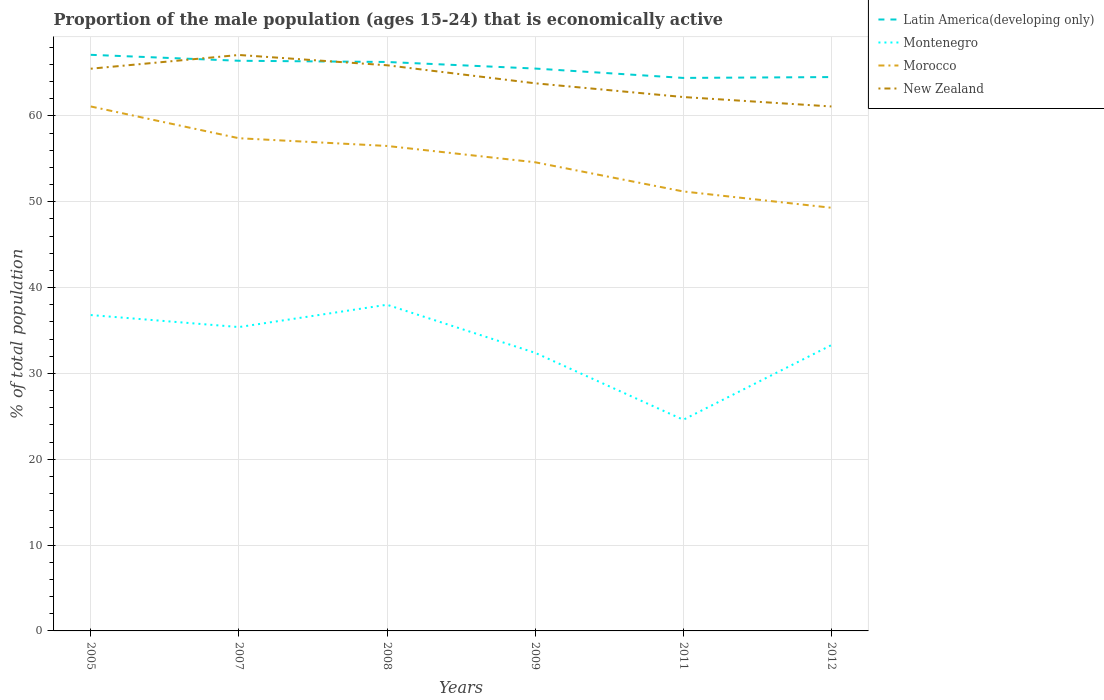Is the number of lines equal to the number of legend labels?
Provide a short and direct response. Yes. Across all years, what is the maximum proportion of the male population that is economically active in Montenegro?
Keep it short and to the point. 24.6. What is the total proportion of the male population that is economically active in New Zealand in the graph?
Offer a terse response. 1.7. What is the difference between the highest and the second highest proportion of the male population that is economically active in Latin America(developing only)?
Offer a very short reply. 2.69. What is the difference between the highest and the lowest proportion of the male population that is economically active in Morocco?
Ensure brevity in your answer.  3. How many lines are there?
Your answer should be very brief. 4. What is the difference between two consecutive major ticks on the Y-axis?
Your answer should be very brief. 10. Does the graph contain any zero values?
Ensure brevity in your answer.  No. Does the graph contain grids?
Your response must be concise. Yes. How are the legend labels stacked?
Offer a very short reply. Vertical. What is the title of the graph?
Provide a short and direct response. Proportion of the male population (ages 15-24) that is economically active. What is the label or title of the X-axis?
Your answer should be very brief. Years. What is the label or title of the Y-axis?
Offer a terse response. % of total population. What is the % of total population in Latin America(developing only) in 2005?
Your response must be concise. 67.12. What is the % of total population in Montenegro in 2005?
Your response must be concise. 36.8. What is the % of total population in Morocco in 2005?
Ensure brevity in your answer.  61.1. What is the % of total population in New Zealand in 2005?
Make the answer very short. 65.5. What is the % of total population of Latin America(developing only) in 2007?
Your answer should be compact. 66.43. What is the % of total population in Montenegro in 2007?
Ensure brevity in your answer.  35.4. What is the % of total population in Morocco in 2007?
Provide a succinct answer. 57.4. What is the % of total population of New Zealand in 2007?
Provide a succinct answer. 67.1. What is the % of total population of Latin America(developing only) in 2008?
Keep it short and to the point. 66.28. What is the % of total population in Morocco in 2008?
Offer a terse response. 56.5. What is the % of total population in New Zealand in 2008?
Offer a terse response. 65.9. What is the % of total population of Latin America(developing only) in 2009?
Offer a very short reply. 65.52. What is the % of total population in Montenegro in 2009?
Keep it short and to the point. 32.4. What is the % of total population in Morocco in 2009?
Offer a very short reply. 54.6. What is the % of total population in New Zealand in 2009?
Your response must be concise. 63.8. What is the % of total population of Latin America(developing only) in 2011?
Provide a succinct answer. 64.43. What is the % of total population of Montenegro in 2011?
Ensure brevity in your answer.  24.6. What is the % of total population in Morocco in 2011?
Your response must be concise. 51.2. What is the % of total population of New Zealand in 2011?
Provide a succinct answer. 62.2. What is the % of total population of Latin America(developing only) in 2012?
Make the answer very short. 64.52. What is the % of total population of Montenegro in 2012?
Your answer should be very brief. 33.3. What is the % of total population of Morocco in 2012?
Your response must be concise. 49.3. What is the % of total population in New Zealand in 2012?
Provide a short and direct response. 61.1. Across all years, what is the maximum % of total population in Latin America(developing only)?
Offer a terse response. 67.12. Across all years, what is the maximum % of total population in Montenegro?
Give a very brief answer. 38. Across all years, what is the maximum % of total population in Morocco?
Keep it short and to the point. 61.1. Across all years, what is the maximum % of total population in New Zealand?
Give a very brief answer. 67.1. Across all years, what is the minimum % of total population of Latin America(developing only)?
Offer a terse response. 64.43. Across all years, what is the minimum % of total population of Montenegro?
Keep it short and to the point. 24.6. Across all years, what is the minimum % of total population in Morocco?
Ensure brevity in your answer.  49.3. Across all years, what is the minimum % of total population in New Zealand?
Make the answer very short. 61.1. What is the total % of total population in Latin America(developing only) in the graph?
Give a very brief answer. 394.29. What is the total % of total population of Montenegro in the graph?
Offer a terse response. 200.5. What is the total % of total population of Morocco in the graph?
Your answer should be compact. 330.1. What is the total % of total population of New Zealand in the graph?
Your answer should be compact. 385.6. What is the difference between the % of total population in Latin America(developing only) in 2005 and that in 2007?
Your answer should be compact. 0.69. What is the difference between the % of total population in Morocco in 2005 and that in 2007?
Offer a terse response. 3.7. What is the difference between the % of total population of Latin America(developing only) in 2005 and that in 2008?
Give a very brief answer. 0.83. What is the difference between the % of total population in Montenegro in 2005 and that in 2008?
Provide a short and direct response. -1.2. What is the difference between the % of total population of New Zealand in 2005 and that in 2008?
Your answer should be very brief. -0.4. What is the difference between the % of total population in Latin America(developing only) in 2005 and that in 2009?
Offer a very short reply. 1.6. What is the difference between the % of total population in Montenegro in 2005 and that in 2009?
Your response must be concise. 4.4. What is the difference between the % of total population of New Zealand in 2005 and that in 2009?
Keep it short and to the point. 1.7. What is the difference between the % of total population of Latin America(developing only) in 2005 and that in 2011?
Offer a terse response. 2.69. What is the difference between the % of total population of New Zealand in 2005 and that in 2011?
Provide a short and direct response. 3.3. What is the difference between the % of total population in Latin America(developing only) in 2005 and that in 2012?
Provide a succinct answer. 2.59. What is the difference between the % of total population in Montenegro in 2005 and that in 2012?
Your answer should be compact. 3.5. What is the difference between the % of total population of Latin America(developing only) in 2007 and that in 2008?
Your response must be concise. 0.14. What is the difference between the % of total population in Montenegro in 2007 and that in 2008?
Offer a very short reply. -2.6. What is the difference between the % of total population of New Zealand in 2007 and that in 2008?
Give a very brief answer. 1.2. What is the difference between the % of total population of Latin America(developing only) in 2007 and that in 2009?
Your answer should be very brief. 0.91. What is the difference between the % of total population of Montenegro in 2007 and that in 2009?
Ensure brevity in your answer.  3. What is the difference between the % of total population of Morocco in 2007 and that in 2009?
Your answer should be very brief. 2.8. What is the difference between the % of total population in Latin America(developing only) in 2007 and that in 2011?
Your response must be concise. 2. What is the difference between the % of total population of Morocco in 2007 and that in 2011?
Your response must be concise. 6.2. What is the difference between the % of total population of Latin America(developing only) in 2007 and that in 2012?
Your answer should be very brief. 1.9. What is the difference between the % of total population of Montenegro in 2007 and that in 2012?
Provide a short and direct response. 2.1. What is the difference between the % of total population in Latin America(developing only) in 2008 and that in 2009?
Give a very brief answer. 0.77. What is the difference between the % of total population of New Zealand in 2008 and that in 2009?
Provide a short and direct response. 2.1. What is the difference between the % of total population in Latin America(developing only) in 2008 and that in 2011?
Offer a terse response. 1.86. What is the difference between the % of total population of Montenegro in 2008 and that in 2011?
Make the answer very short. 13.4. What is the difference between the % of total population of New Zealand in 2008 and that in 2011?
Provide a short and direct response. 3.7. What is the difference between the % of total population in Latin America(developing only) in 2008 and that in 2012?
Your response must be concise. 1.76. What is the difference between the % of total population of Montenegro in 2008 and that in 2012?
Provide a short and direct response. 4.7. What is the difference between the % of total population of Morocco in 2008 and that in 2012?
Your answer should be very brief. 7.2. What is the difference between the % of total population of New Zealand in 2008 and that in 2012?
Your response must be concise. 4.8. What is the difference between the % of total population of Latin America(developing only) in 2009 and that in 2011?
Ensure brevity in your answer.  1.09. What is the difference between the % of total population in Latin America(developing only) in 2009 and that in 2012?
Provide a short and direct response. 0.99. What is the difference between the % of total population in Morocco in 2009 and that in 2012?
Give a very brief answer. 5.3. What is the difference between the % of total population in New Zealand in 2009 and that in 2012?
Offer a very short reply. 2.7. What is the difference between the % of total population in Latin America(developing only) in 2011 and that in 2012?
Your answer should be very brief. -0.1. What is the difference between the % of total population of Montenegro in 2011 and that in 2012?
Ensure brevity in your answer.  -8.7. What is the difference between the % of total population of New Zealand in 2011 and that in 2012?
Offer a very short reply. 1.1. What is the difference between the % of total population in Latin America(developing only) in 2005 and the % of total population in Montenegro in 2007?
Make the answer very short. 31.72. What is the difference between the % of total population of Latin America(developing only) in 2005 and the % of total population of Morocco in 2007?
Your answer should be compact. 9.72. What is the difference between the % of total population in Latin America(developing only) in 2005 and the % of total population in New Zealand in 2007?
Ensure brevity in your answer.  0.02. What is the difference between the % of total population in Montenegro in 2005 and the % of total population in Morocco in 2007?
Keep it short and to the point. -20.6. What is the difference between the % of total population of Montenegro in 2005 and the % of total population of New Zealand in 2007?
Give a very brief answer. -30.3. What is the difference between the % of total population of Latin America(developing only) in 2005 and the % of total population of Montenegro in 2008?
Ensure brevity in your answer.  29.12. What is the difference between the % of total population of Latin America(developing only) in 2005 and the % of total population of Morocco in 2008?
Your response must be concise. 10.62. What is the difference between the % of total population in Latin America(developing only) in 2005 and the % of total population in New Zealand in 2008?
Make the answer very short. 1.22. What is the difference between the % of total population in Montenegro in 2005 and the % of total population in Morocco in 2008?
Offer a very short reply. -19.7. What is the difference between the % of total population of Montenegro in 2005 and the % of total population of New Zealand in 2008?
Ensure brevity in your answer.  -29.1. What is the difference between the % of total population in Latin America(developing only) in 2005 and the % of total population in Montenegro in 2009?
Provide a short and direct response. 34.72. What is the difference between the % of total population in Latin America(developing only) in 2005 and the % of total population in Morocco in 2009?
Keep it short and to the point. 12.52. What is the difference between the % of total population of Latin America(developing only) in 2005 and the % of total population of New Zealand in 2009?
Give a very brief answer. 3.32. What is the difference between the % of total population of Montenegro in 2005 and the % of total population of Morocco in 2009?
Provide a short and direct response. -17.8. What is the difference between the % of total population of Latin America(developing only) in 2005 and the % of total population of Montenegro in 2011?
Keep it short and to the point. 42.52. What is the difference between the % of total population of Latin America(developing only) in 2005 and the % of total population of Morocco in 2011?
Provide a short and direct response. 15.92. What is the difference between the % of total population in Latin America(developing only) in 2005 and the % of total population in New Zealand in 2011?
Your answer should be very brief. 4.92. What is the difference between the % of total population of Montenegro in 2005 and the % of total population of Morocco in 2011?
Your answer should be compact. -14.4. What is the difference between the % of total population in Montenegro in 2005 and the % of total population in New Zealand in 2011?
Keep it short and to the point. -25.4. What is the difference between the % of total population in Morocco in 2005 and the % of total population in New Zealand in 2011?
Offer a terse response. -1.1. What is the difference between the % of total population in Latin America(developing only) in 2005 and the % of total population in Montenegro in 2012?
Offer a terse response. 33.82. What is the difference between the % of total population in Latin America(developing only) in 2005 and the % of total population in Morocco in 2012?
Ensure brevity in your answer.  17.82. What is the difference between the % of total population in Latin America(developing only) in 2005 and the % of total population in New Zealand in 2012?
Offer a very short reply. 6.02. What is the difference between the % of total population in Montenegro in 2005 and the % of total population in Morocco in 2012?
Offer a very short reply. -12.5. What is the difference between the % of total population in Montenegro in 2005 and the % of total population in New Zealand in 2012?
Provide a succinct answer. -24.3. What is the difference between the % of total population of Latin America(developing only) in 2007 and the % of total population of Montenegro in 2008?
Your response must be concise. 28.43. What is the difference between the % of total population in Latin America(developing only) in 2007 and the % of total population in Morocco in 2008?
Keep it short and to the point. 9.93. What is the difference between the % of total population of Latin America(developing only) in 2007 and the % of total population of New Zealand in 2008?
Your response must be concise. 0.53. What is the difference between the % of total population in Montenegro in 2007 and the % of total population in Morocco in 2008?
Give a very brief answer. -21.1. What is the difference between the % of total population of Montenegro in 2007 and the % of total population of New Zealand in 2008?
Keep it short and to the point. -30.5. What is the difference between the % of total population of Latin America(developing only) in 2007 and the % of total population of Montenegro in 2009?
Provide a succinct answer. 34.03. What is the difference between the % of total population of Latin America(developing only) in 2007 and the % of total population of Morocco in 2009?
Keep it short and to the point. 11.83. What is the difference between the % of total population in Latin America(developing only) in 2007 and the % of total population in New Zealand in 2009?
Make the answer very short. 2.63. What is the difference between the % of total population in Montenegro in 2007 and the % of total population in Morocco in 2009?
Provide a short and direct response. -19.2. What is the difference between the % of total population in Montenegro in 2007 and the % of total population in New Zealand in 2009?
Your response must be concise. -28.4. What is the difference between the % of total population in Morocco in 2007 and the % of total population in New Zealand in 2009?
Keep it short and to the point. -6.4. What is the difference between the % of total population of Latin America(developing only) in 2007 and the % of total population of Montenegro in 2011?
Your answer should be compact. 41.83. What is the difference between the % of total population in Latin America(developing only) in 2007 and the % of total population in Morocco in 2011?
Keep it short and to the point. 15.23. What is the difference between the % of total population of Latin America(developing only) in 2007 and the % of total population of New Zealand in 2011?
Your answer should be very brief. 4.23. What is the difference between the % of total population of Montenegro in 2007 and the % of total population of Morocco in 2011?
Offer a very short reply. -15.8. What is the difference between the % of total population in Montenegro in 2007 and the % of total population in New Zealand in 2011?
Make the answer very short. -26.8. What is the difference between the % of total population in Morocco in 2007 and the % of total population in New Zealand in 2011?
Provide a short and direct response. -4.8. What is the difference between the % of total population in Latin America(developing only) in 2007 and the % of total population in Montenegro in 2012?
Provide a succinct answer. 33.13. What is the difference between the % of total population in Latin America(developing only) in 2007 and the % of total population in Morocco in 2012?
Your answer should be very brief. 17.13. What is the difference between the % of total population of Latin America(developing only) in 2007 and the % of total population of New Zealand in 2012?
Ensure brevity in your answer.  5.33. What is the difference between the % of total population of Montenegro in 2007 and the % of total population of Morocco in 2012?
Provide a short and direct response. -13.9. What is the difference between the % of total population in Montenegro in 2007 and the % of total population in New Zealand in 2012?
Give a very brief answer. -25.7. What is the difference between the % of total population in Latin America(developing only) in 2008 and the % of total population in Montenegro in 2009?
Your response must be concise. 33.88. What is the difference between the % of total population of Latin America(developing only) in 2008 and the % of total population of Morocco in 2009?
Make the answer very short. 11.68. What is the difference between the % of total population of Latin America(developing only) in 2008 and the % of total population of New Zealand in 2009?
Your answer should be very brief. 2.48. What is the difference between the % of total population of Montenegro in 2008 and the % of total population of Morocco in 2009?
Provide a succinct answer. -16.6. What is the difference between the % of total population in Montenegro in 2008 and the % of total population in New Zealand in 2009?
Provide a succinct answer. -25.8. What is the difference between the % of total population in Latin America(developing only) in 2008 and the % of total population in Montenegro in 2011?
Make the answer very short. 41.68. What is the difference between the % of total population of Latin America(developing only) in 2008 and the % of total population of Morocco in 2011?
Offer a very short reply. 15.08. What is the difference between the % of total population in Latin America(developing only) in 2008 and the % of total population in New Zealand in 2011?
Offer a terse response. 4.08. What is the difference between the % of total population of Montenegro in 2008 and the % of total population of Morocco in 2011?
Provide a short and direct response. -13.2. What is the difference between the % of total population in Montenegro in 2008 and the % of total population in New Zealand in 2011?
Make the answer very short. -24.2. What is the difference between the % of total population of Morocco in 2008 and the % of total population of New Zealand in 2011?
Give a very brief answer. -5.7. What is the difference between the % of total population of Latin America(developing only) in 2008 and the % of total population of Montenegro in 2012?
Offer a terse response. 32.98. What is the difference between the % of total population in Latin America(developing only) in 2008 and the % of total population in Morocco in 2012?
Provide a succinct answer. 16.98. What is the difference between the % of total population in Latin America(developing only) in 2008 and the % of total population in New Zealand in 2012?
Provide a short and direct response. 5.18. What is the difference between the % of total population of Montenegro in 2008 and the % of total population of Morocco in 2012?
Your answer should be compact. -11.3. What is the difference between the % of total population of Montenegro in 2008 and the % of total population of New Zealand in 2012?
Keep it short and to the point. -23.1. What is the difference between the % of total population of Latin America(developing only) in 2009 and the % of total population of Montenegro in 2011?
Ensure brevity in your answer.  40.92. What is the difference between the % of total population of Latin America(developing only) in 2009 and the % of total population of Morocco in 2011?
Offer a terse response. 14.32. What is the difference between the % of total population in Latin America(developing only) in 2009 and the % of total population in New Zealand in 2011?
Provide a succinct answer. 3.32. What is the difference between the % of total population in Montenegro in 2009 and the % of total population in Morocco in 2011?
Offer a terse response. -18.8. What is the difference between the % of total population in Montenegro in 2009 and the % of total population in New Zealand in 2011?
Provide a succinct answer. -29.8. What is the difference between the % of total population in Morocco in 2009 and the % of total population in New Zealand in 2011?
Offer a very short reply. -7.6. What is the difference between the % of total population in Latin America(developing only) in 2009 and the % of total population in Montenegro in 2012?
Ensure brevity in your answer.  32.22. What is the difference between the % of total population in Latin America(developing only) in 2009 and the % of total population in Morocco in 2012?
Give a very brief answer. 16.22. What is the difference between the % of total population in Latin America(developing only) in 2009 and the % of total population in New Zealand in 2012?
Provide a short and direct response. 4.42. What is the difference between the % of total population of Montenegro in 2009 and the % of total population of Morocco in 2012?
Make the answer very short. -16.9. What is the difference between the % of total population of Montenegro in 2009 and the % of total population of New Zealand in 2012?
Your answer should be compact. -28.7. What is the difference between the % of total population in Morocco in 2009 and the % of total population in New Zealand in 2012?
Your response must be concise. -6.5. What is the difference between the % of total population in Latin America(developing only) in 2011 and the % of total population in Montenegro in 2012?
Offer a terse response. 31.13. What is the difference between the % of total population of Latin America(developing only) in 2011 and the % of total population of Morocco in 2012?
Your response must be concise. 15.13. What is the difference between the % of total population of Latin America(developing only) in 2011 and the % of total population of New Zealand in 2012?
Provide a short and direct response. 3.33. What is the difference between the % of total population of Montenegro in 2011 and the % of total population of Morocco in 2012?
Your response must be concise. -24.7. What is the difference between the % of total population of Montenegro in 2011 and the % of total population of New Zealand in 2012?
Provide a short and direct response. -36.5. What is the average % of total population in Latin America(developing only) per year?
Your response must be concise. 65.72. What is the average % of total population in Montenegro per year?
Your answer should be compact. 33.42. What is the average % of total population of Morocco per year?
Ensure brevity in your answer.  55.02. What is the average % of total population in New Zealand per year?
Make the answer very short. 64.27. In the year 2005, what is the difference between the % of total population of Latin America(developing only) and % of total population of Montenegro?
Your answer should be compact. 30.32. In the year 2005, what is the difference between the % of total population of Latin America(developing only) and % of total population of Morocco?
Give a very brief answer. 6.02. In the year 2005, what is the difference between the % of total population in Latin America(developing only) and % of total population in New Zealand?
Make the answer very short. 1.62. In the year 2005, what is the difference between the % of total population in Montenegro and % of total population in Morocco?
Offer a very short reply. -24.3. In the year 2005, what is the difference between the % of total population in Montenegro and % of total population in New Zealand?
Give a very brief answer. -28.7. In the year 2007, what is the difference between the % of total population in Latin America(developing only) and % of total population in Montenegro?
Your answer should be compact. 31.03. In the year 2007, what is the difference between the % of total population in Latin America(developing only) and % of total population in Morocco?
Ensure brevity in your answer.  9.03. In the year 2007, what is the difference between the % of total population in Latin America(developing only) and % of total population in New Zealand?
Your answer should be compact. -0.67. In the year 2007, what is the difference between the % of total population in Montenegro and % of total population in Morocco?
Offer a very short reply. -22. In the year 2007, what is the difference between the % of total population of Montenegro and % of total population of New Zealand?
Ensure brevity in your answer.  -31.7. In the year 2008, what is the difference between the % of total population of Latin America(developing only) and % of total population of Montenegro?
Provide a short and direct response. 28.28. In the year 2008, what is the difference between the % of total population of Latin America(developing only) and % of total population of Morocco?
Ensure brevity in your answer.  9.78. In the year 2008, what is the difference between the % of total population of Latin America(developing only) and % of total population of New Zealand?
Keep it short and to the point. 0.38. In the year 2008, what is the difference between the % of total population of Montenegro and % of total population of Morocco?
Provide a short and direct response. -18.5. In the year 2008, what is the difference between the % of total population in Montenegro and % of total population in New Zealand?
Your answer should be very brief. -27.9. In the year 2008, what is the difference between the % of total population of Morocco and % of total population of New Zealand?
Your answer should be very brief. -9.4. In the year 2009, what is the difference between the % of total population in Latin America(developing only) and % of total population in Montenegro?
Your answer should be compact. 33.12. In the year 2009, what is the difference between the % of total population of Latin America(developing only) and % of total population of Morocco?
Make the answer very short. 10.92. In the year 2009, what is the difference between the % of total population in Latin America(developing only) and % of total population in New Zealand?
Provide a short and direct response. 1.72. In the year 2009, what is the difference between the % of total population in Montenegro and % of total population in Morocco?
Provide a succinct answer. -22.2. In the year 2009, what is the difference between the % of total population of Montenegro and % of total population of New Zealand?
Your response must be concise. -31.4. In the year 2011, what is the difference between the % of total population in Latin America(developing only) and % of total population in Montenegro?
Offer a very short reply. 39.83. In the year 2011, what is the difference between the % of total population of Latin America(developing only) and % of total population of Morocco?
Make the answer very short. 13.23. In the year 2011, what is the difference between the % of total population of Latin America(developing only) and % of total population of New Zealand?
Give a very brief answer. 2.23. In the year 2011, what is the difference between the % of total population in Montenegro and % of total population in Morocco?
Provide a succinct answer. -26.6. In the year 2011, what is the difference between the % of total population in Montenegro and % of total population in New Zealand?
Give a very brief answer. -37.6. In the year 2012, what is the difference between the % of total population of Latin America(developing only) and % of total population of Montenegro?
Make the answer very short. 31.22. In the year 2012, what is the difference between the % of total population in Latin America(developing only) and % of total population in Morocco?
Offer a very short reply. 15.22. In the year 2012, what is the difference between the % of total population in Latin America(developing only) and % of total population in New Zealand?
Your answer should be compact. 3.42. In the year 2012, what is the difference between the % of total population of Montenegro and % of total population of New Zealand?
Ensure brevity in your answer.  -27.8. In the year 2012, what is the difference between the % of total population of Morocco and % of total population of New Zealand?
Offer a terse response. -11.8. What is the ratio of the % of total population in Latin America(developing only) in 2005 to that in 2007?
Ensure brevity in your answer.  1.01. What is the ratio of the % of total population of Montenegro in 2005 to that in 2007?
Ensure brevity in your answer.  1.04. What is the ratio of the % of total population of Morocco in 2005 to that in 2007?
Give a very brief answer. 1.06. What is the ratio of the % of total population in New Zealand in 2005 to that in 2007?
Your response must be concise. 0.98. What is the ratio of the % of total population of Latin America(developing only) in 2005 to that in 2008?
Offer a very short reply. 1.01. What is the ratio of the % of total population in Montenegro in 2005 to that in 2008?
Offer a terse response. 0.97. What is the ratio of the % of total population of Morocco in 2005 to that in 2008?
Your response must be concise. 1.08. What is the ratio of the % of total population of New Zealand in 2005 to that in 2008?
Offer a very short reply. 0.99. What is the ratio of the % of total population of Latin America(developing only) in 2005 to that in 2009?
Give a very brief answer. 1.02. What is the ratio of the % of total population of Montenegro in 2005 to that in 2009?
Offer a terse response. 1.14. What is the ratio of the % of total population of Morocco in 2005 to that in 2009?
Your response must be concise. 1.12. What is the ratio of the % of total population in New Zealand in 2005 to that in 2009?
Make the answer very short. 1.03. What is the ratio of the % of total population of Latin America(developing only) in 2005 to that in 2011?
Your answer should be very brief. 1.04. What is the ratio of the % of total population in Montenegro in 2005 to that in 2011?
Keep it short and to the point. 1.5. What is the ratio of the % of total population in Morocco in 2005 to that in 2011?
Offer a very short reply. 1.19. What is the ratio of the % of total population of New Zealand in 2005 to that in 2011?
Make the answer very short. 1.05. What is the ratio of the % of total population of Latin America(developing only) in 2005 to that in 2012?
Provide a short and direct response. 1.04. What is the ratio of the % of total population of Montenegro in 2005 to that in 2012?
Your answer should be very brief. 1.11. What is the ratio of the % of total population of Morocco in 2005 to that in 2012?
Offer a very short reply. 1.24. What is the ratio of the % of total population in New Zealand in 2005 to that in 2012?
Offer a very short reply. 1.07. What is the ratio of the % of total population in Montenegro in 2007 to that in 2008?
Give a very brief answer. 0.93. What is the ratio of the % of total population in Morocco in 2007 to that in 2008?
Your answer should be compact. 1.02. What is the ratio of the % of total population of New Zealand in 2007 to that in 2008?
Make the answer very short. 1.02. What is the ratio of the % of total population in Latin America(developing only) in 2007 to that in 2009?
Provide a short and direct response. 1.01. What is the ratio of the % of total population in Montenegro in 2007 to that in 2009?
Give a very brief answer. 1.09. What is the ratio of the % of total population in Morocco in 2007 to that in 2009?
Offer a very short reply. 1.05. What is the ratio of the % of total population in New Zealand in 2007 to that in 2009?
Ensure brevity in your answer.  1.05. What is the ratio of the % of total population of Latin America(developing only) in 2007 to that in 2011?
Your answer should be very brief. 1.03. What is the ratio of the % of total population in Montenegro in 2007 to that in 2011?
Your response must be concise. 1.44. What is the ratio of the % of total population in Morocco in 2007 to that in 2011?
Keep it short and to the point. 1.12. What is the ratio of the % of total population of New Zealand in 2007 to that in 2011?
Provide a short and direct response. 1.08. What is the ratio of the % of total population in Latin America(developing only) in 2007 to that in 2012?
Provide a succinct answer. 1.03. What is the ratio of the % of total population of Montenegro in 2007 to that in 2012?
Keep it short and to the point. 1.06. What is the ratio of the % of total population of Morocco in 2007 to that in 2012?
Keep it short and to the point. 1.16. What is the ratio of the % of total population in New Zealand in 2007 to that in 2012?
Provide a succinct answer. 1.1. What is the ratio of the % of total population of Latin America(developing only) in 2008 to that in 2009?
Ensure brevity in your answer.  1.01. What is the ratio of the % of total population of Montenegro in 2008 to that in 2009?
Give a very brief answer. 1.17. What is the ratio of the % of total population of Morocco in 2008 to that in 2009?
Provide a succinct answer. 1.03. What is the ratio of the % of total population in New Zealand in 2008 to that in 2009?
Give a very brief answer. 1.03. What is the ratio of the % of total population of Latin America(developing only) in 2008 to that in 2011?
Offer a very short reply. 1.03. What is the ratio of the % of total population in Montenegro in 2008 to that in 2011?
Make the answer very short. 1.54. What is the ratio of the % of total population in Morocco in 2008 to that in 2011?
Offer a very short reply. 1.1. What is the ratio of the % of total population in New Zealand in 2008 to that in 2011?
Give a very brief answer. 1.06. What is the ratio of the % of total population in Latin America(developing only) in 2008 to that in 2012?
Provide a short and direct response. 1.03. What is the ratio of the % of total population of Montenegro in 2008 to that in 2012?
Provide a short and direct response. 1.14. What is the ratio of the % of total population of Morocco in 2008 to that in 2012?
Provide a short and direct response. 1.15. What is the ratio of the % of total population in New Zealand in 2008 to that in 2012?
Your answer should be compact. 1.08. What is the ratio of the % of total population in Latin America(developing only) in 2009 to that in 2011?
Provide a short and direct response. 1.02. What is the ratio of the % of total population of Montenegro in 2009 to that in 2011?
Your response must be concise. 1.32. What is the ratio of the % of total population of Morocco in 2009 to that in 2011?
Provide a succinct answer. 1.07. What is the ratio of the % of total population in New Zealand in 2009 to that in 2011?
Make the answer very short. 1.03. What is the ratio of the % of total population in Latin America(developing only) in 2009 to that in 2012?
Ensure brevity in your answer.  1.02. What is the ratio of the % of total population of Montenegro in 2009 to that in 2012?
Ensure brevity in your answer.  0.97. What is the ratio of the % of total population of Morocco in 2009 to that in 2012?
Provide a succinct answer. 1.11. What is the ratio of the % of total population in New Zealand in 2009 to that in 2012?
Your answer should be very brief. 1.04. What is the ratio of the % of total population of Latin America(developing only) in 2011 to that in 2012?
Make the answer very short. 1. What is the ratio of the % of total population of Montenegro in 2011 to that in 2012?
Your answer should be very brief. 0.74. What is the difference between the highest and the second highest % of total population of Latin America(developing only)?
Offer a terse response. 0.69. What is the difference between the highest and the second highest % of total population in Montenegro?
Your answer should be compact. 1.2. What is the difference between the highest and the second highest % of total population of New Zealand?
Your answer should be very brief. 1.2. What is the difference between the highest and the lowest % of total population of Latin America(developing only)?
Provide a succinct answer. 2.69. What is the difference between the highest and the lowest % of total population in New Zealand?
Offer a terse response. 6. 